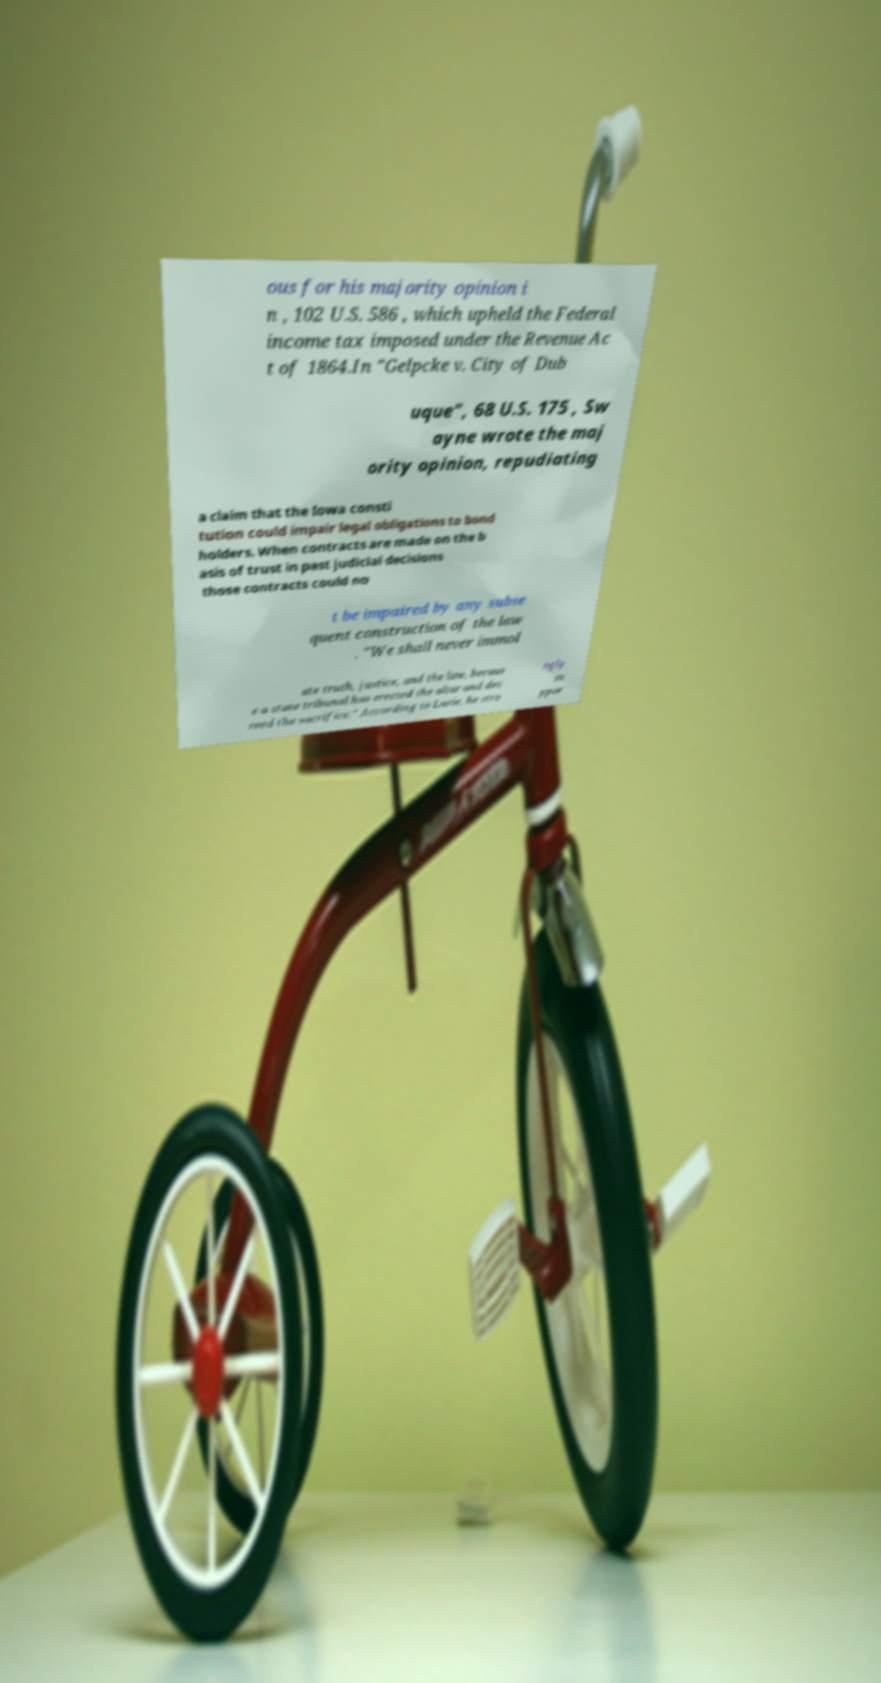There's text embedded in this image that I need extracted. Can you transcribe it verbatim? ous for his majority opinion i n , 102 U.S. 586 , which upheld the Federal income tax imposed under the Revenue Ac t of 1864.In "Gelpcke v. City of Dub uque", 68 U.S. 175 , Sw ayne wrote the maj ority opinion, repudiating a claim that the Iowa consti tution could impair legal obligations to bond holders. When contracts are made on the b asis of trust in past judicial decisions those contracts could no t be impaired by any subse quent construction of the law . "We shall never immol ate truth, justice, and the law, becaus e a state tribunal has erected the altar and dec reed the sacrifice." According to Lurie, he stro ngly su ppor 